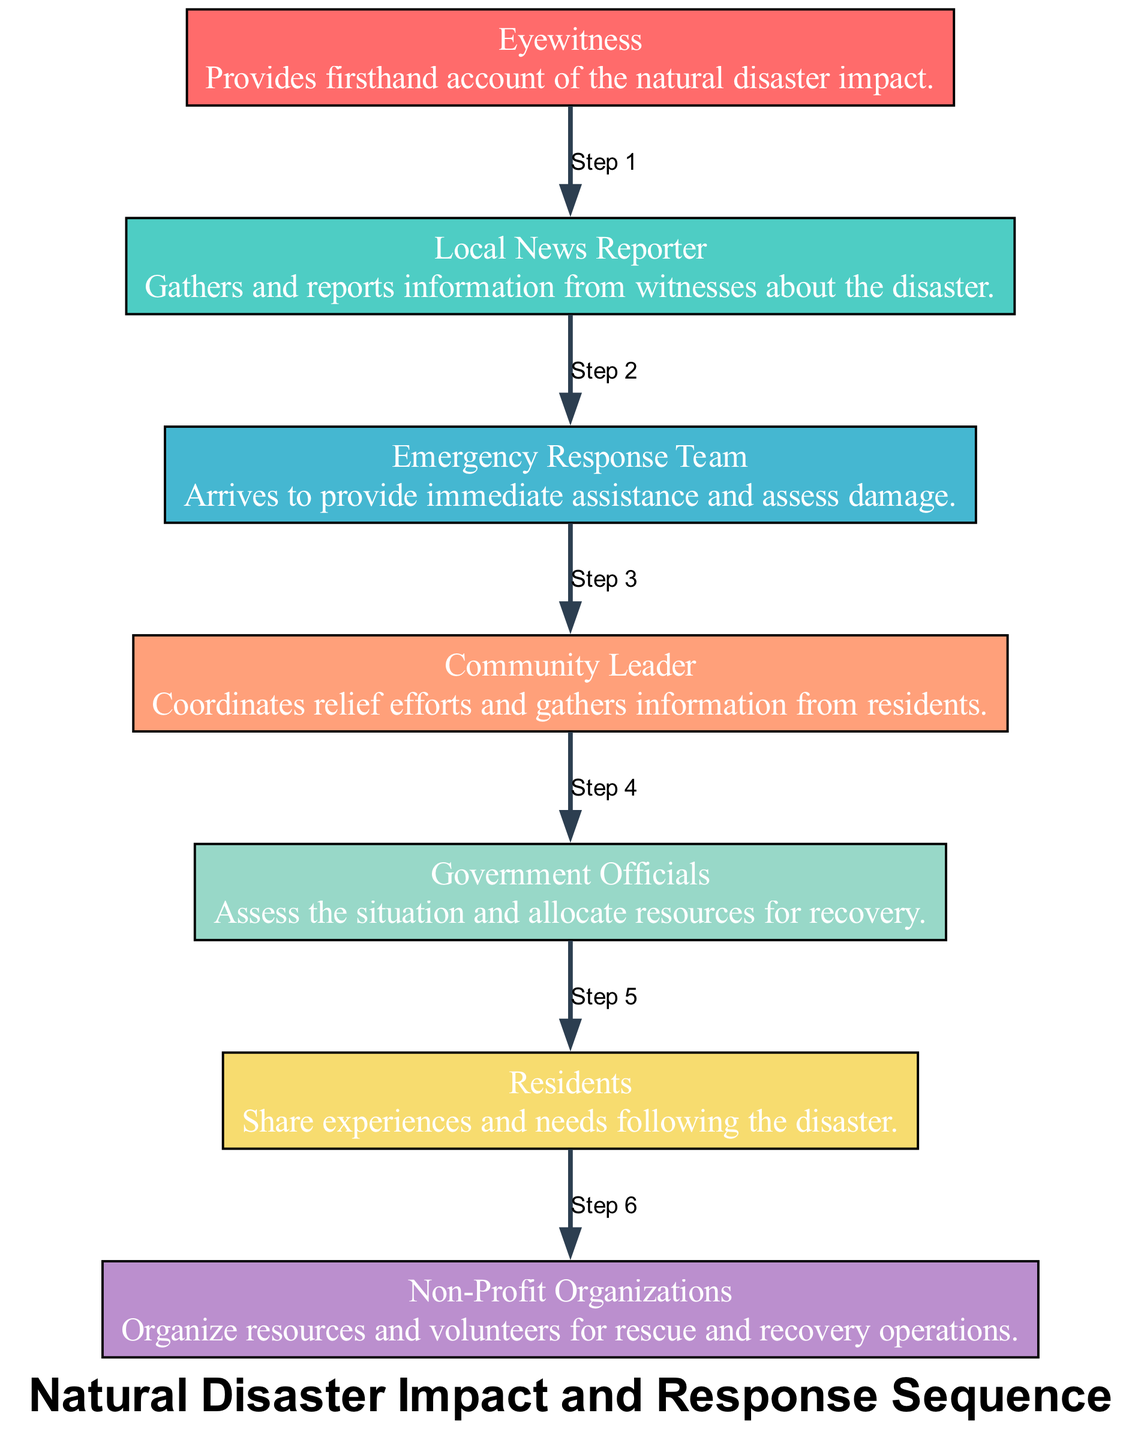What is the total number of actors in the diagram? The diagram lists seven unique actors involved in the sequence, each representing different roles and contributions in response to the natural disaster. The actors are Eyewitness, Local News Reporter, Emergency Response Team, Community Leader, Government Officials, Residents, and Non-Profit Organizations.
Answer: Seven Which actor provides a firsthand account of the natural disaster impact? The diagram specifies that the Eyewitness actor is responsible for providing the firsthand account of the disaster's impact. Each actor is labeled with a description that identifies their role clearly.
Answer: Eyewitness What is the immediate role of the Emergency Response Team? The Emergency Response Team arrives at the scene to provide immediate assistance and assess the damage caused by the disaster, as described in their role in the diagram.
Answer: Immediate assistance Which actor coordinates relief efforts within the community? The diagram states that the Community Leader is the one who coordinates relief efforts, highlighting their essential role in organizing community support following the disaster.
Answer: Community Leader How many edges are used to represent the sequence of events? There are six edges drawn in the diagram that indicate the flow of actions and interactions among the actors from one step to the next, which corresponds to the number of actors minus one.
Answer: Six What relationship exists between Eyewitness and Local News Reporter? The diagram shows an edge between the Eyewitness and the Local News Reporter, indicating that the Eyewitness provides information to the Local News Reporter, who gathers and reports on the information.
Answer: Information exchange Which two actors work together to assess the situation and allocate resources for recovery? The Government Officials and the Emergency Response Team collaborate in assessing the situation and appropriate resource allocation for recovery efforts following the natural disaster. This collaborative effort is noted in the diagram's sequence.
Answer: Government Officials, Emergency Response Team What role do Non-Profit Organizations play in the sequence? The diagram indicates that Non-Profit Organizations are responsible for organizing resources and volunteers specifically for the rescue and recovery operations after the disaster, highlighting their vital support role.
Answer: Organize resources and volunteers 